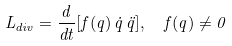<formula> <loc_0><loc_0><loc_500><loc_500>L _ { d i v } = \frac { d } { d t } [ f ( q ) \, \dot { q } \, \ddot { q } ] , \ \ f ( q ) \ne 0</formula> 